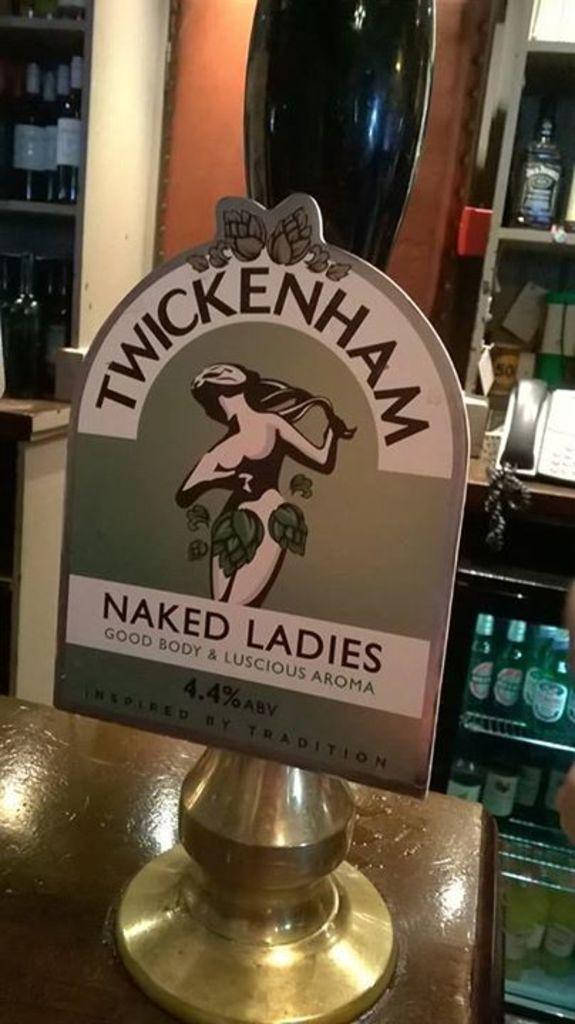<image>
Render a clear and concise summary of the photo. A Naked Ladies sign is sitting on a shelf. 